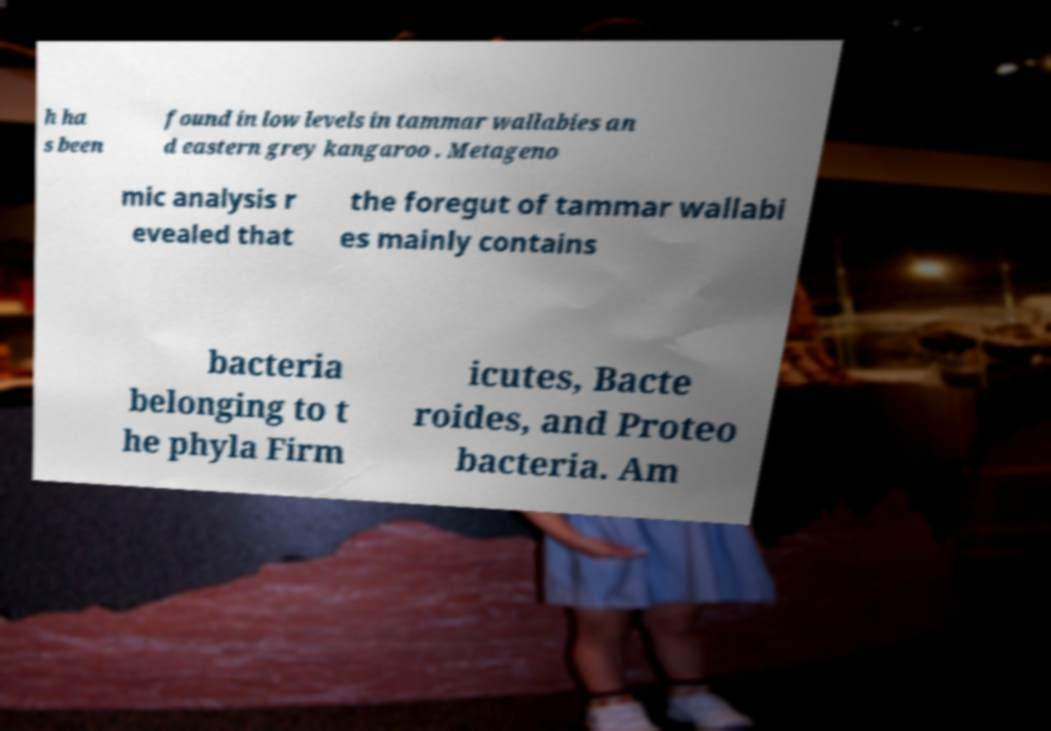I need the written content from this picture converted into text. Can you do that? h ha s been found in low levels in tammar wallabies an d eastern grey kangaroo . Metageno mic analysis r evealed that the foregut of tammar wallabi es mainly contains bacteria belonging to t he phyla Firm icutes, Bacte roides, and Proteo bacteria. Am 